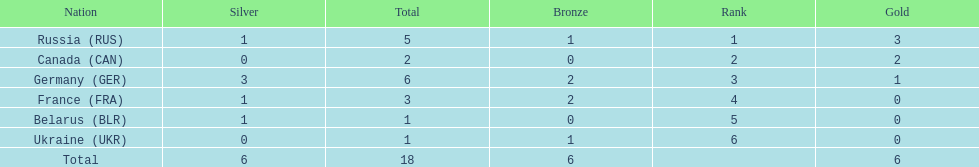Parse the full table. {'header': ['Nation', 'Silver', 'Total', 'Bronze', 'Rank', 'Gold'], 'rows': [['Russia\xa0(RUS)', '1', '5', '1', '1', '3'], ['Canada\xa0(CAN)', '0', '2', '0', '2', '2'], ['Germany\xa0(GER)', '3', '6', '2', '3', '1'], ['France\xa0(FRA)', '1', '3', '2', '4', '0'], ['Belarus\xa0(BLR)', '1', '1', '0', '5', '0'], ['Ukraine\xa0(UKR)', '0', '1', '1', '6', '0'], ['Total', '6', '18', '6', '', '6']]} What were the only 3 countries to win gold medals at the the 1994 winter olympics biathlon? Russia (RUS), Canada (CAN), Germany (GER). 